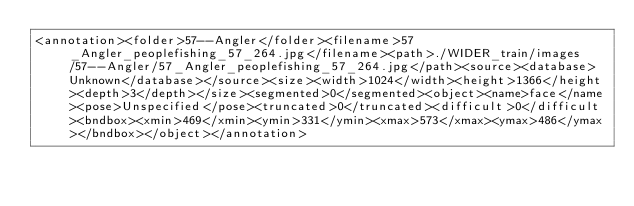Convert code to text. <code><loc_0><loc_0><loc_500><loc_500><_XML_><annotation><folder>57--Angler</folder><filename>57_Angler_peoplefishing_57_264.jpg</filename><path>./WIDER_train/images/57--Angler/57_Angler_peoplefishing_57_264.jpg</path><source><database>Unknown</database></source><size><width>1024</width><height>1366</height><depth>3</depth></size><segmented>0</segmented><object><name>face</name><pose>Unspecified</pose><truncated>0</truncated><difficult>0</difficult><bndbox><xmin>469</xmin><ymin>331</ymin><xmax>573</xmax><ymax>486</ymax></bndbox></object></annotation></code> 